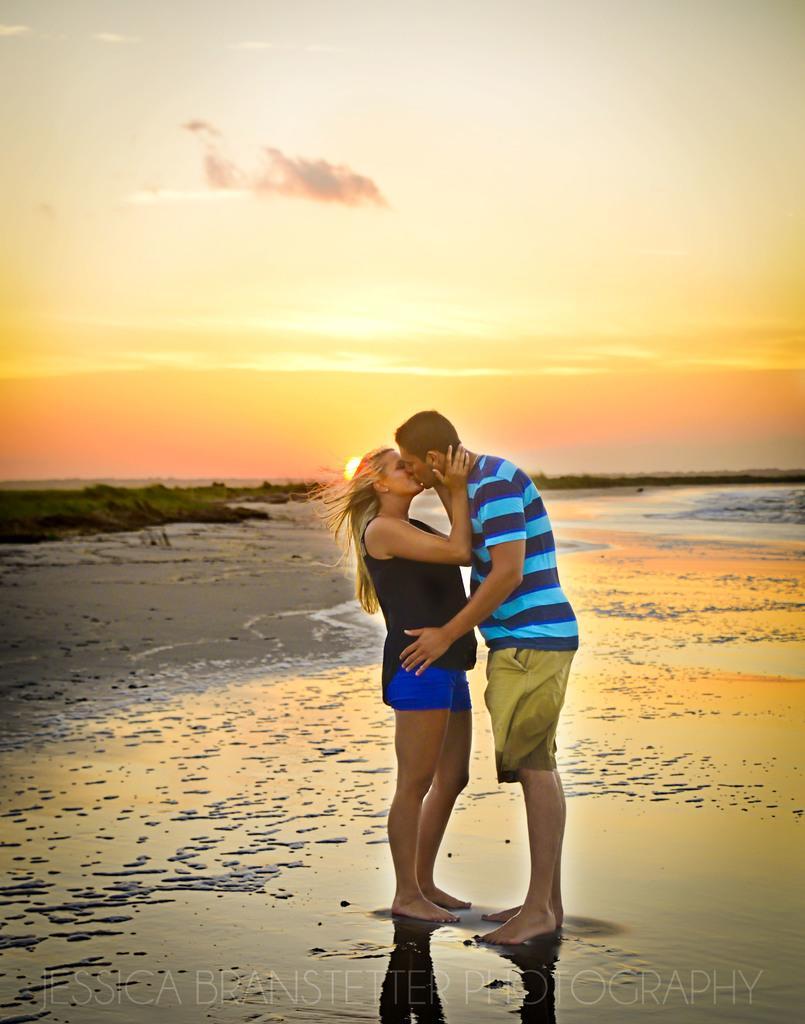Can you describe this image briefly? In this image I can see two people. I can see the water. In the background, I can see the trees and the sun. I can also see the clouds in the sky. 